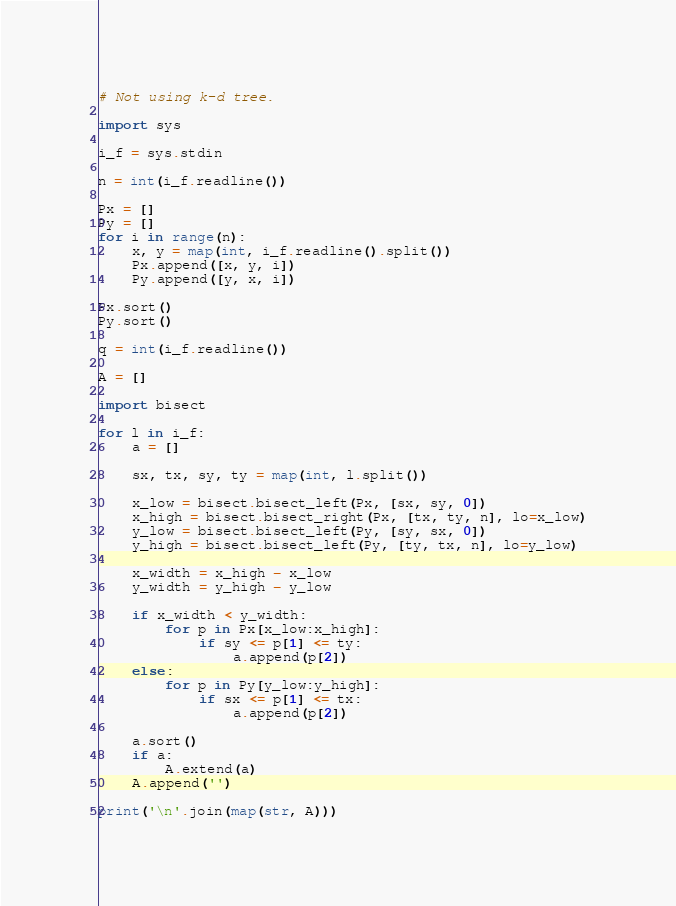<code> <loc_0><loc_0><loc_500><loc_500><_Python_># Not using k-d tree.

import sys
 
i_f = sys.stdin
 
n = int(i_f.readline())

Px = []
Py = []
for i in range(n):
    x, y = map(int, i_f.readline().split())
    Px.append([x, y, i])
    Py.append([y, x, i])

Px.sort()
Py.sort()

q = int(i_f.readline())

A = []

import bisect

for l in i_f:
    a = []
    
    sx, tx, sy, ty = map(int, l.split())
    
    x_low = bisect.bisect_left(Px, [sx, sy, 0])
    x_high = bisect.bisect_right(Px, [tx, ty, n], lo=x_low)
    y_low = bisect.bisect_left(Py, [sy, sx, 0])
    y_high = bisect.bisect_left(Py, [ty, tx, n], lo=y_low)
    
    x_width = x_high - x_low
    y_width = y_high - y_low

    if x_width < y_width:
        for p in Px[x_low:x_high]:
            if sy <= p[1] <= ty:
                a.append(p[2])
    else:
        for p in Py[y_low:y_high]:
            if sx <= p[1] <= tx:
                a.append(p[2])

    a.sort()
    if a:
        A.extend(a)
    A.append('')

print('\n'.join(map(str, A)))</code> 